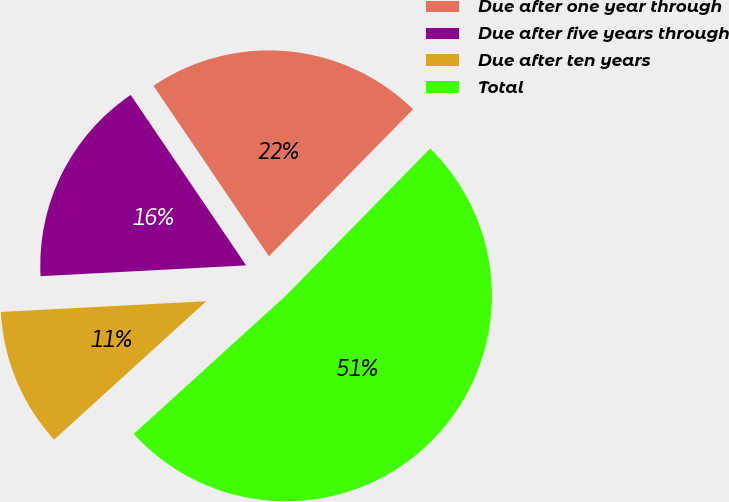Convert chart to OTSL. <chart><loc_0><loc_0><loc_500><loc_500><pie_chart><fcel>Due after one year through<fcel>Due after five years through<fcel>Due after ten years<fcel>Total<nl><fcel>21.82%<fcel>16.36%<fcel>10.91%<fcel>50.91%<nl></chart> 